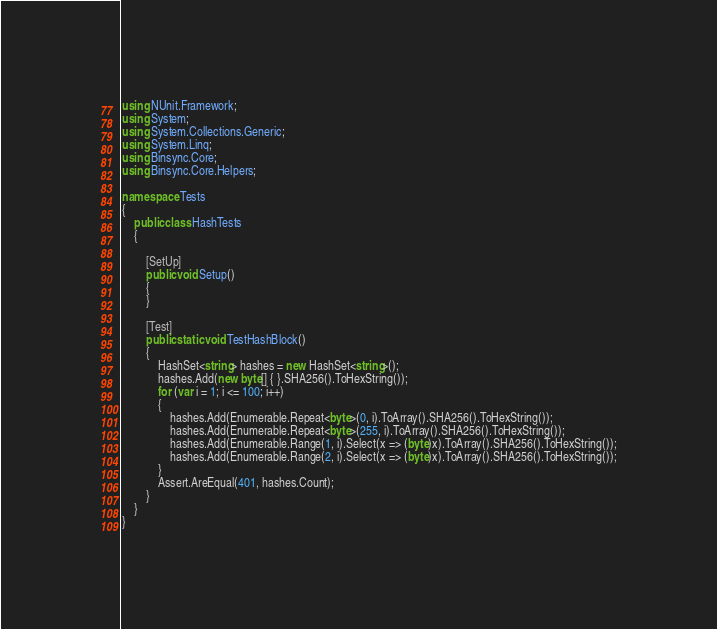Convert code to text. <code><loc_0><loc_0><loc_500><loc_500><_C#_>using NUnit.Framework;
using System;
using System.Collections.Generic;
using System.Linq;
using Binsync.Core;
using Binsync.Core.Helpers;

namespace Tests
{
	public class HashTests
	{

		[SetUp]
		public void Setup()
		{
		}

		[Test]
		public static void TestHashBlock()
		{
			HashSet<string> hashes = new HashSet<string>();
			hashes.Add(new byte[] { }.SHA256().ToHexString());
			for (var i = 1; i <= 100; i++)
			{
				hashes.Add(Enumerable.Repeat<byte>(0, i).ToArray().SHA256().ToHexString());
				hashes.Add(Enumerable.Repeat<byte>(255, i).ToArray().SHA256().ToHexString());
				hashes.Add(Enumerable.Range(1, i).Select(x => (byte)x).ToArray().SHA256().ToHexString());
				hashes.Add(Enumerable.Range(2, i).Select(x => (byte)x).ToArray().SHA256().ToHexString());
			}
			Assert.AreEqual(401, hashes.Count);
		}
	}
}</code> 